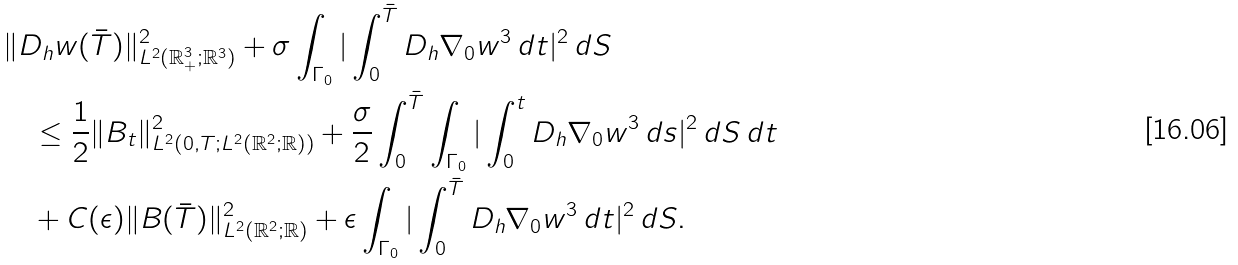<formula> <loc_0><loc_0><loc_500><loc_500>& \| D _ { h } w ( \bar { T } ) \| ^ { 2 } _ { L ^ { 2 } ( \mathbb { R } ^ { 3 } _ { + } ; \mathbb { R } ^ { 3 } ) } + \sigma \int _ { \Gamma _ { 0 } } | \int _ { 0 } ^ { \bar { T } } D _ { h } \nabla _ { 0 } w ^ { 3 } \, d t | ^ { 2 } \, d S \\ & \quad \leq \frac { 1 } { 2 } \| B _ { t } \| ^ { 2 } _ { L ^ { 2 } ( 0 , T ; L ^ { 2 } ( \mathbb { R } ^ { 2 } ; \mathbb { R } ) ) } + \frac { \sigma } { 2 } \int _ { 0 } ^ { \bar { T } } \int _ { \Gamma _ { 0 } } | \int _ { 0 } ^ { t } D _ { h } \nabla _ { 0 } w ^ { 3 } \, d s | ^ { 2 } \, d S \, d t \\ & \quad + C ( \epsilon ) \| B ( \bar { T } ) \| ^ { 2 } _ { L ^ { 2 } ( \mathbb { R } ^ { 2 } ; \mathbb { R } ) } + \epsilon \int _ { \Gamma _ { 0 } } | \int _ { 0 } ^ { \bar { T } } D _ { h } \nabla _ { 0 } w ^ { 3 } \, d t | ^ { 2 } \, d S .</formula> 